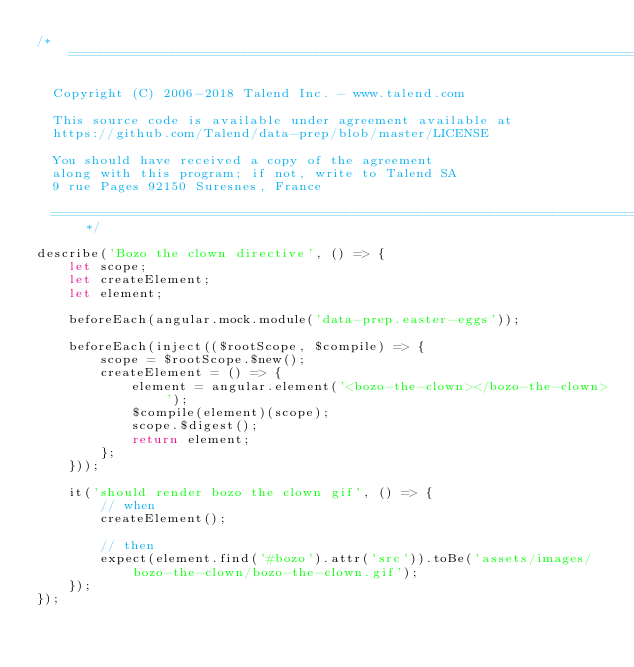<code> <loc_0><loc_0><loc_500><loc_500><_JavaScript_>/*  ============================================================================

  Copyright (C) 2006-2018 Talend Inc. - www.talend.com

  This source code is available under agreement available at
  https://github.com/Talend/data-prep/blob/master/LICENSE

  You should have received a copy of the agreement
  along with this program; if not, write to Talend SA
  9 rue Pages 92150 Suresnes, France

  ============================================================================*/

describe('Bozo the clown directive', () => {
	let scope;
	let createElement;
	let element;

	beforeEach(angular.mock.module('data-prep.easter-eggs'));

	beforeEach(inject(($rootScope, $compile) => {
		scope = $rootScope.$new();
		createElement = () => {
			element = angular.element('<bozo-the-clown></bozo-the-clown>');
			$compile(element)(scope);
			scope.$digest();
			return element;
		};
	}));

	it('should render bozo the clown gif', () => {
		// when
		createElement();

		// then
		expect(element.find('#bozo').attr('src')).toBe('assets/images/bozo-the-clown/bozo-the-clown.gif');
	});
});
</code> 